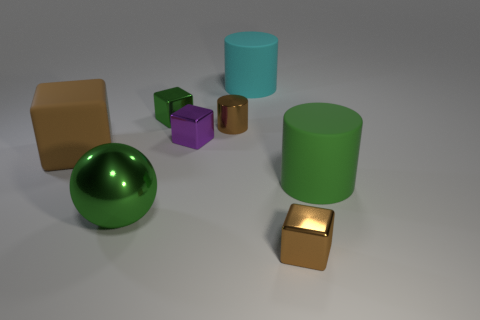The large sphere is what color?
Your response must be concise. Green. Are there any green balls that are to the left of the green thing that is behind the green cylinder?
Offer a terse response. Yes. What is the shape of the shiny object that is right of the matte cylinder that is behind the large brown rubber block?
Offer a terse response. Cube. Are there fewer big metallic things than small cyan matte cubes?
Give a very brief answer. No. Are the large green cylinder and the small green block made of the same material?
Make the answer very short. No. What color is the tiny object that is both behind the small purple thing and to the right of the purple block?
Offer a very short reply. Brown. Is there a brown metal cylinder of the same size as the cyan object?
Offer a very short reply. No. There is a cylinder that is right of the large matte thing behind the big brown rubber thing; how big is it?
Your response must be concise. Large. Is the number of tiny metal things on the left side of the big cyan rubber cylinder less than the number of green rubber cylinders?
Keep it short and to the point. No. Is the big sphere the same color as the small cylinder?
Keep it short and to the point. No. 